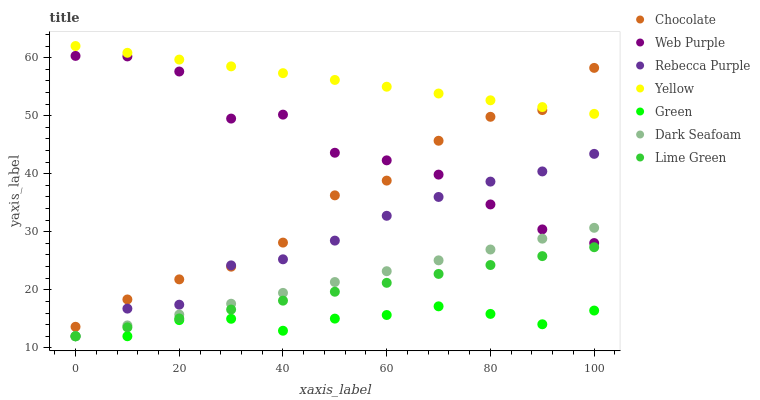Does Green have the minimum area under the curve?
Answer yes or no. Yes. Does Yellow have the maximum area under the curve?
Answer yes or no. Yes. Does Chocolate have the minimum area under the curve?
Answer yes or no. No. Does Chocolate have the maximum area under the curve?
Answer yes or no. No. Is Yellow the smoothest?
Answer yes or no. Yes. Is Web Purple the roughest?
Answer yes or no. Yes. Is Chocolate the smoothest?
Answer yes or no. No. Is Chocolate the roughest?
Answer yes or no. No. Does Dark Seafoam have the lowest value?
Answer yes or no. Yes. Does Chocolate have the lowest value?
Answer yes or no. No. Does Yellow have the highest value?
Answer yes or no. Yes. Does Chocolate have the highest value?
Answer yes or no. No. Is Rebecca Purple less than Yellow?
Answer yes or no. Yes. Is Yellow greater than Green?
Answer yes or no. Yes. Does Lime Green intersect Dark Seafoam?
Answer yes or no. Yes. Is Lime Green less than Dark Seafoam?
Answer yes or no. No. Is Lime Green greater than Dark Seafoam?
Answer yes or no. No. Does Rebecca Purple intersect Yellow?
Answer yes or no. No. 